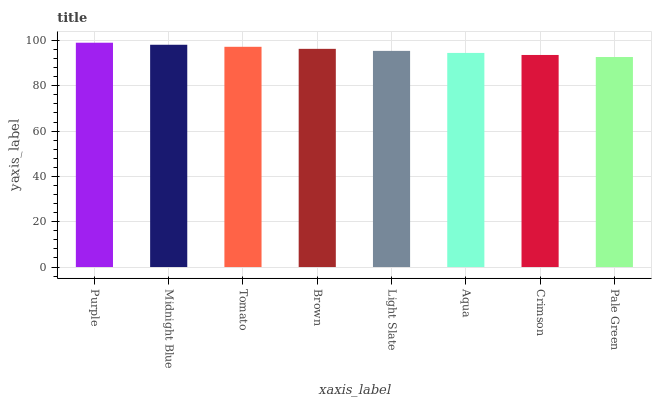Is Pale Green the minimum?
Answer yes or no. Yes. Is Purple the maximum?
Answer yes or no. Yes. Is Midnight Blue the minimum?
Answer yes or no. No. Is Midnight Blue the maximum?
Answer yes or no. No. Is Purple greater than Midnight Blue?
Answer yes or no. Yes. Is Midnight Blue less than Purple?
Answer yes or no. Yes. Is Midnight Blue greater than Purple?
Answer yes or no. No. Is Purple less than Midnight Blue?
Answer yes or no. No. Is Brown the high median?
Answer yes or no. Yes. Is Light Slate the low median?
Answer yes or no. Yes. Is Crimson the high median?
Answer yes or no. No. Is Aqua the low median?
Answer yes or no. No. 